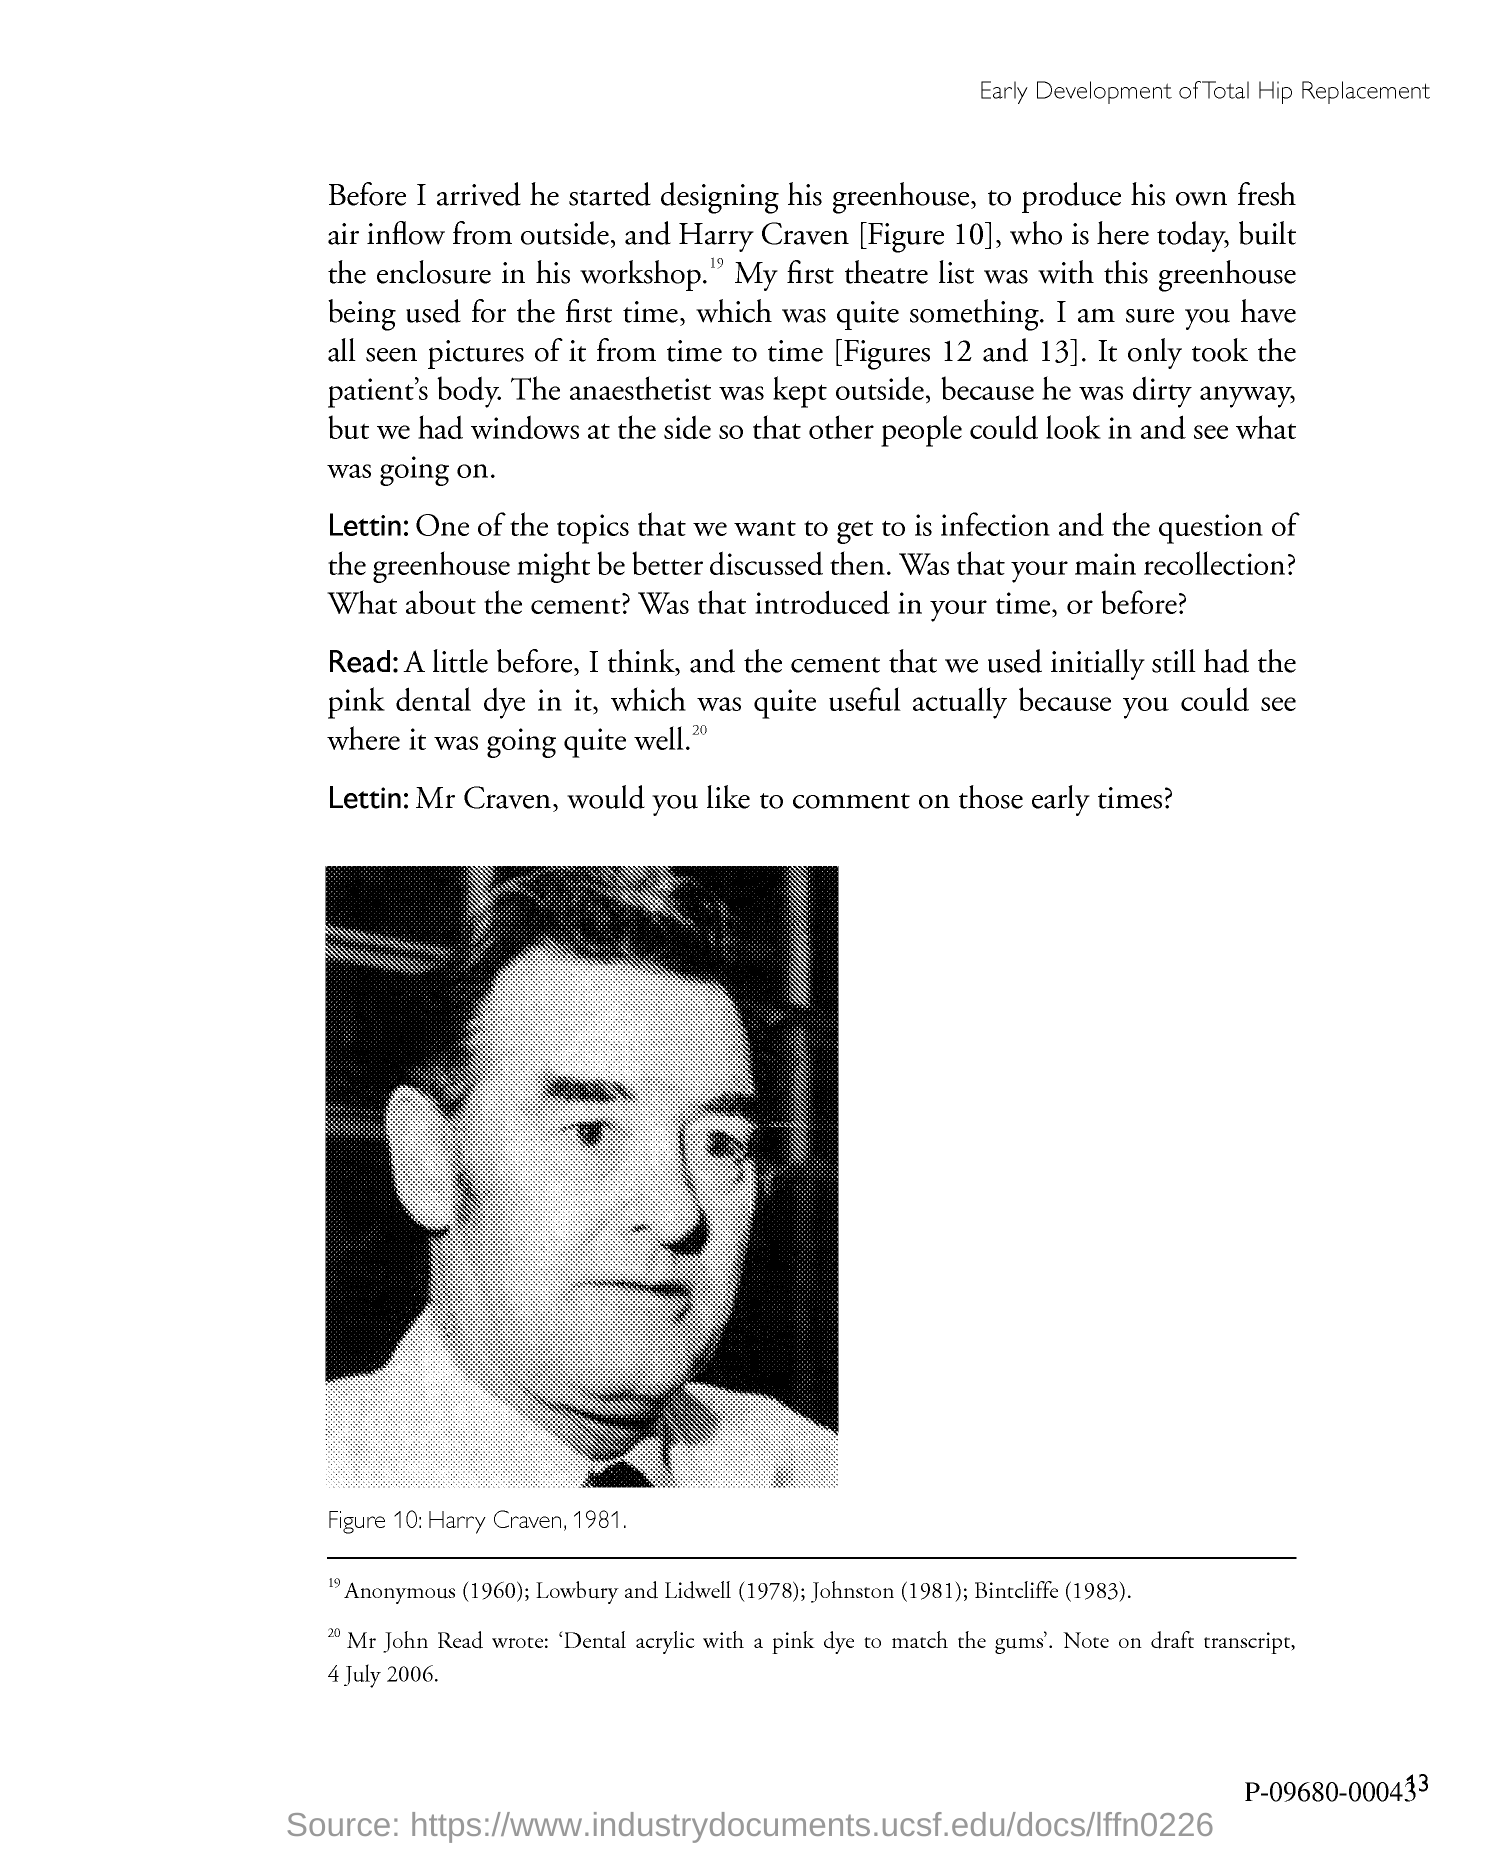What is the name of the person shown in the image?
Provide a succinct answer. Craven. What is the Page Number?
Make the answer very short. 13. 